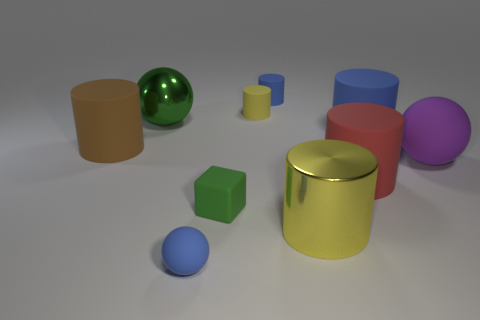Subtract 3 cylinders. How many cylinders are left? 3 Subtract all red cylinders. How many cylinders are left? 5 Subtract all blue rubber cylinders. How many cylinders are left? 4 Subtract all gray cylinders. Subtract all green blocks. How many cylinders are left? 6 Subtract all cylinders. How many objects are left? 4 Subtract 0 cyan cylinders. How many objects are left? 10 Subtract all matte cylinders. Subtract all matte cubes. How many objects are left? 4 Add 8 green blocks. How many green blocks are left? 9 Add 6 brown matte cubes. How many brown matte cubes exist? 6 